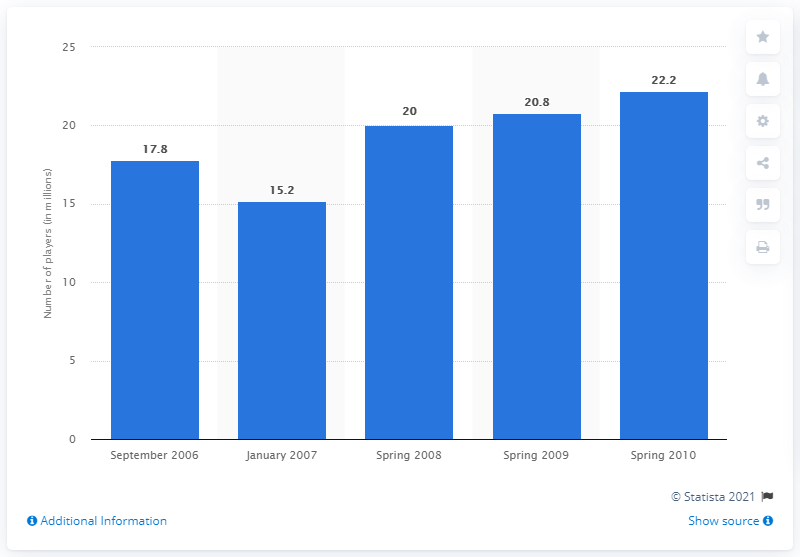List a handful of essential elements in this visual. In Spring 2008, there were approximately 20 million people who played poker online for money. 